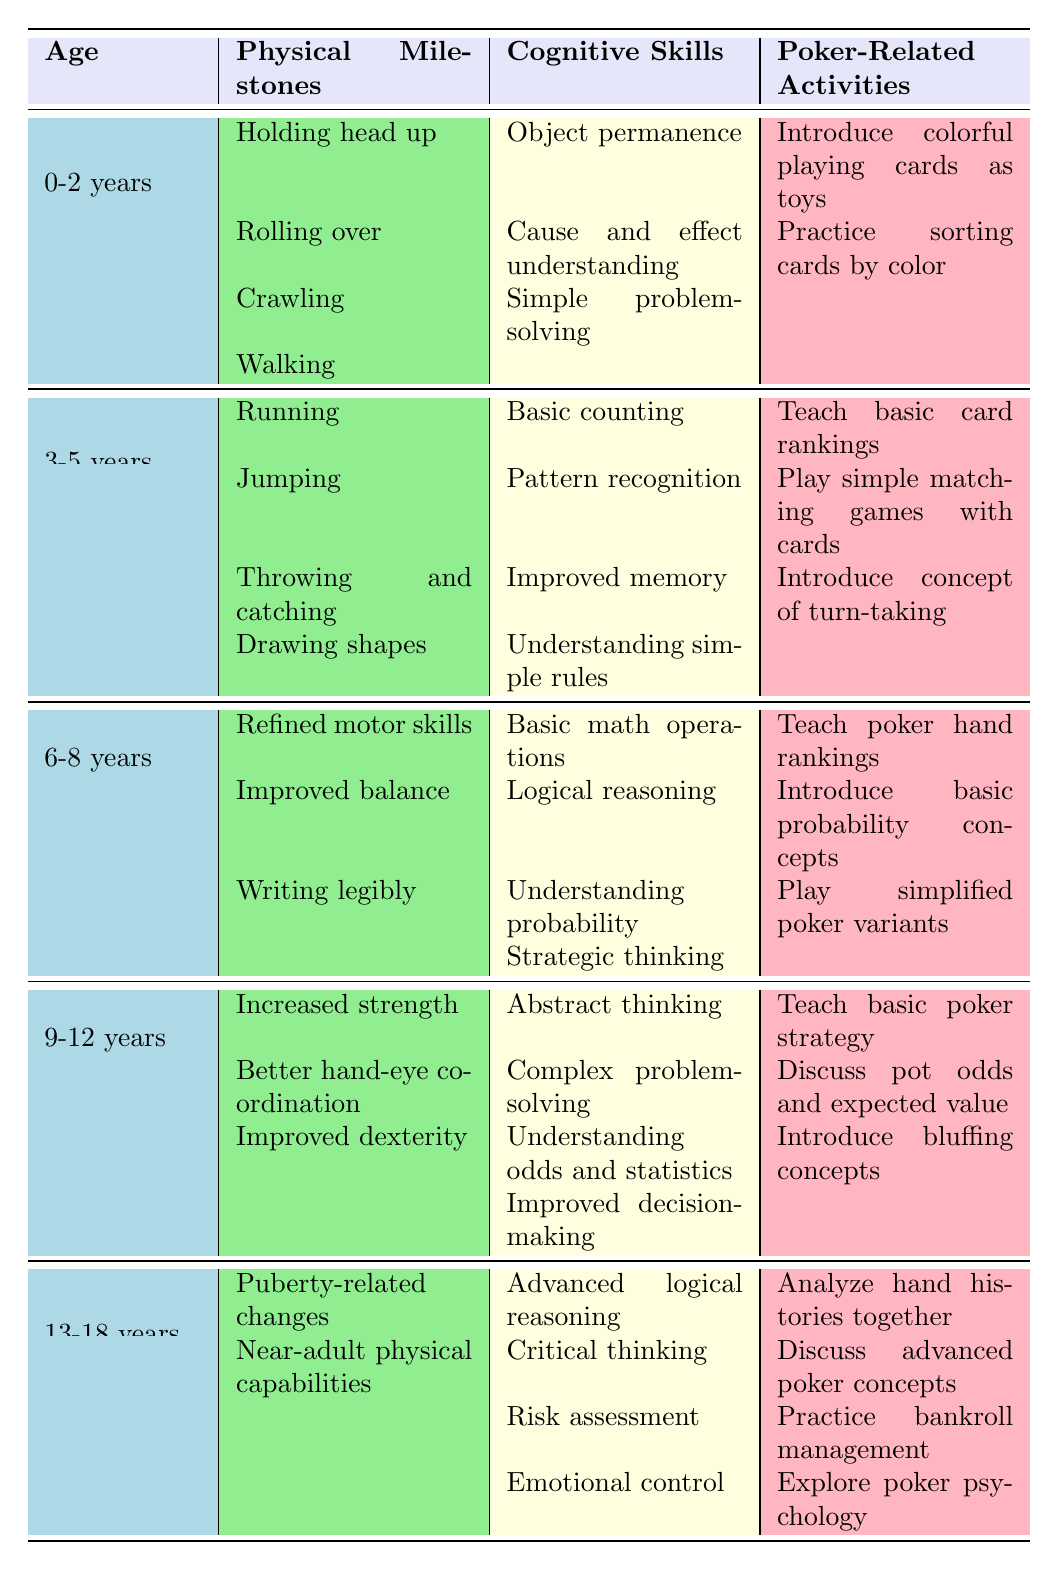What are the cognitive skills developed in children aged 3-5 years? In the age group of 3-5 years, the table lists four cognitive skills: Basic counting, Pattern recognition, Improved memory, and Understanding simple rules.
Answer: Basic counting, Pattern recognition, Improved memory, Understanding simple rules What physical milestones are achieved by children aged 9-12 years? For children aged 9-12 years, the physical milestones include Increased strength, Better hand-eye coordination, and Improved dexterity.
Answer: Increased strength, Better hand-eye coordination, Improved dexterity How many poker-related activities are suggested for children aged 6-8 years? The table lists three poker-related activities for children aged 6-8 years: Teach poker hand rankings, Introduce basic probability concepts, and Play simplified poker variants.
Answer: 3 Does the cognitive skill of strategic thinking appear in the table for children aged 0-2 years? The table indicates that children aged 0-2 years have cognitive skills such as Object permanence, Cause and effect understanding, and Simple problem-solving, but not strategic thinking.
Answer: No What is the age group that begins to understand probability? The age group that starts understanding probability according to the table is 6-8 years.
Answer: 6-8 years If a parent wants to introduce bluffing concepts to their child, which age group should they focus on? The table specifies that bluffing concepts are introduced in the age group of 13-18 years.
Answer: 13-18 years How many cognitive skills are listed for the age group of 13-18 years, and what is their average level of complexity? There are four cognitive skills listed for the 13-18 years age group: Advanced logical reasoning, Critical thinking, Risk assessment, and Emotional control. Determining their average complexity requires assessing that all of them are advanced skills, hence the average complexity is high.
Answer: 4, high What is the relationship between the physical milestones and cognitive skills for children aged 0-2 years? The table lists physical milestones including Holding head up, Rolling over, Crawling, and Walking. The cognitive skills for this age group, such as Object permanence, relate to the ability to explore and interact physically with the environment. This suggests that physical development supports cognitive growth during this age.
Answer: Interdependent Which poker-related activity is common for both age groups 3-5 years and 6-8 years? The table shows that there are no overlapping poker-related activities between the age groups of 3-5 years and 6-8 years; they have unique activities tailored to their developmental stages.
Answer: None What change in cognitive skills occurs from age 9-12 years to 13-18 years? Transitioning from age 9-12 years to 13-18 years, there is a shift from more abstract thinking and complex problem-solving to advanced logical reasoning and emotional control, indicating a progression towards higher order cognitive skills and personal development.
Answer: Progression to higher order skills 